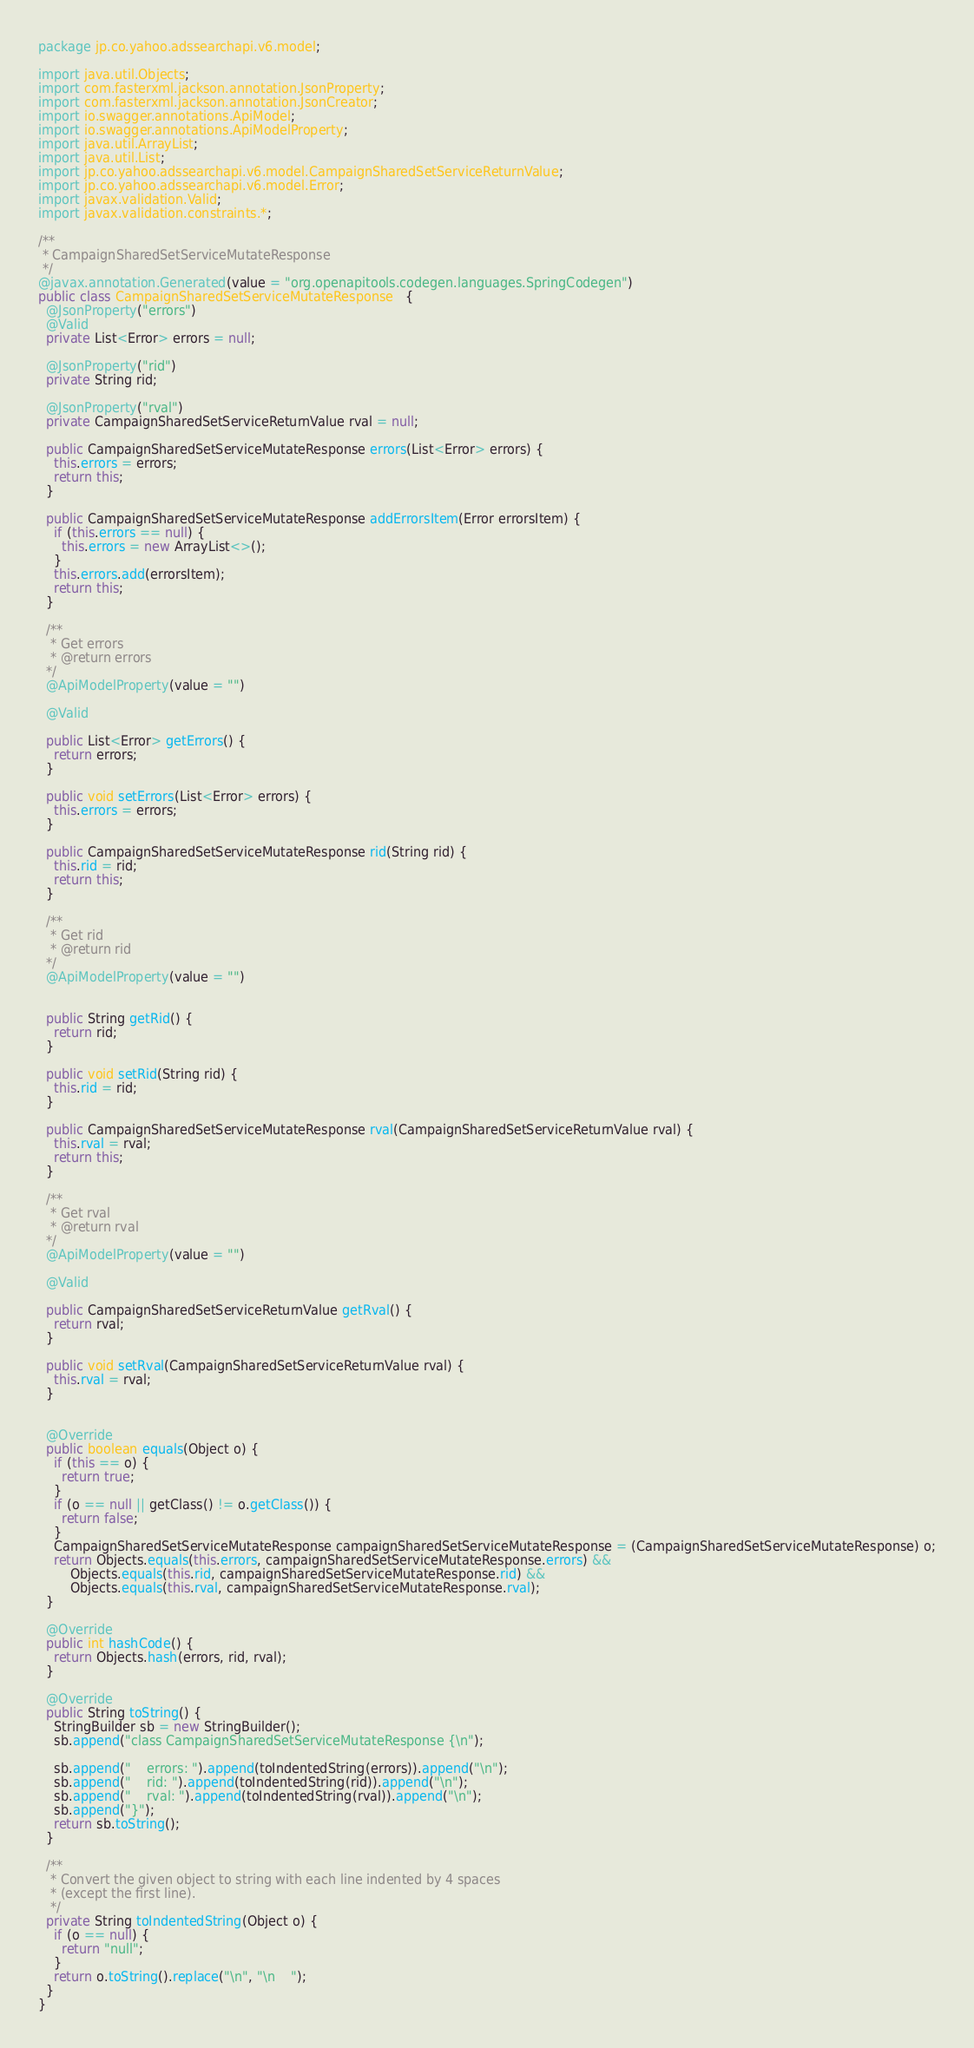Convert code to text. <code><loc_0><loc_0><loc_500><loc_500><_Java_>package jp.co.yahoo.adssearchapi.v6.model;

import java.util.Objects;
import com.fasterxml.jackson.annotation.JsonProperty;
import com.fasterxml.jackson.annotation.JsonCreator;
import io.swagger.annotations.ApiModel;
import io.swagger.annotations.ApiModelProperty;
import java.util.ArrayList;
import java.util.List;
import jp.co.yahoo.adssearchapi.v6.model.CampaignSharedSetServiceReturnValue;
import jp.co.yahoo.adssearchapi.v6.model.Error;
import javax.validation.Valid;
import javax.validation.constraints.*;

/**
 * CampaignSharedSetServiceMutateResponse
 */
@javax.annotation.Generated(value = "org.openapitools.codegen.languages.SpringCodegen")
public class CampaignSharedSetServiceMutateResponse   {
  @JsonProperty("errors")
  @Valid
  private List<Error> errors = null;

  @JsonProperty("rid")
  private String rid;

  @JsonProperty("rval")
  private CampaignSharedSetServiceReturnValue rval = null;

  public CampaignSharedSetServiceMutateResponse errors(List<Error> errors) {
    this.errors = errors;
    return this;
  }

  public CampaignSharedSetServiceMutateResponse addErrorsItem(Error errorsItem) {
    if (this.errors == null) {
      this.errors = new ArrayList<>();
    }
    this.errors.add(errorsItem);
    return this;
  }

  /**
   * Get errors
   * @return errors
  */
  @ApiModelProperty(value = "")

  @Valid

  public List<Error> getErrors() {
    return errors;
  }

  public void setErrors(List<Error> errors) {
    this.errors = errors;
  }

  public CampaignSharedSetServiceMutateResponse rid(String rid) {
    this.rid = rid;
    return this;
  }

  /**
   * Get rid
   * @return rid
  */
  @ApiModelProperty(value = "")


  public String getRid() {
    return rid;
  }

  public void setRid(String rid) {
    this.rid = rid;
  }

  public CampaignSharedSetServiceMutateResponse rval(CampaignSharedSetServiceReturnValue rval) {
    this.rval = rval;
    return this;
  }

  /**
   * Get rval
   * @return rval
  */
  @ApiModelProperty(value = "")

  @Valid

  public CampaignSharedSetServiceReturnValue getRval() {
    return rval;
  }

  public void setRval(CampaignSharedSetServiceReturnValue rval) {
    this.rval = rval;
  }


  @Override
  public boolean equals(Object o) {
    if (this == o) {
      return true;
    }
    if (o == null || getClass() != o.getClass()) {
      return false;
    }
    CampaignSharedSetServiceMutateResponse campaignSharedSetServiceMutateResponse = (CampaignSharedSetServiceMutateResponse) o;
    return Objects.equals(this.errors, campaignSharedSetServiceMutateResponse.errors) &&
        Objects.equals(this.rid, campaignSharedSetServiceMutateResponse.rid) &&
        Objects.equals(this.rval, campaignSharedSetServiceMutateResponse.rval);
  }

  @Override
  public int hashCode() {
    return Objects.hash(errors, rid, rval);
  }

  @Override
  public String toString() {
    StringBuilder sb = new StringBuilder();
    sb.append("class CampaignSharedSetServiceMutateResponse {\n");
    
    sb.append("    errors: ").append(toIndentedString(errors)).append("\n");
    sb.append("    rid: ").append(toIndentedString(rid)).append("\n");
    sb.append("    rval: ").append(toIndentedString(rval)).append("\n");
    sb.append("}");
    return sb.toString();
  }

  /**
   * Convert the given object to string with each line indented by 4 spaces
   * (except the first line).
   */
  private String toIndentedString(Object o) {
    if (o == null) {
      return "null";
    }
    return o.toString().replace("\n", "\n    ");
  }
}

</code> 